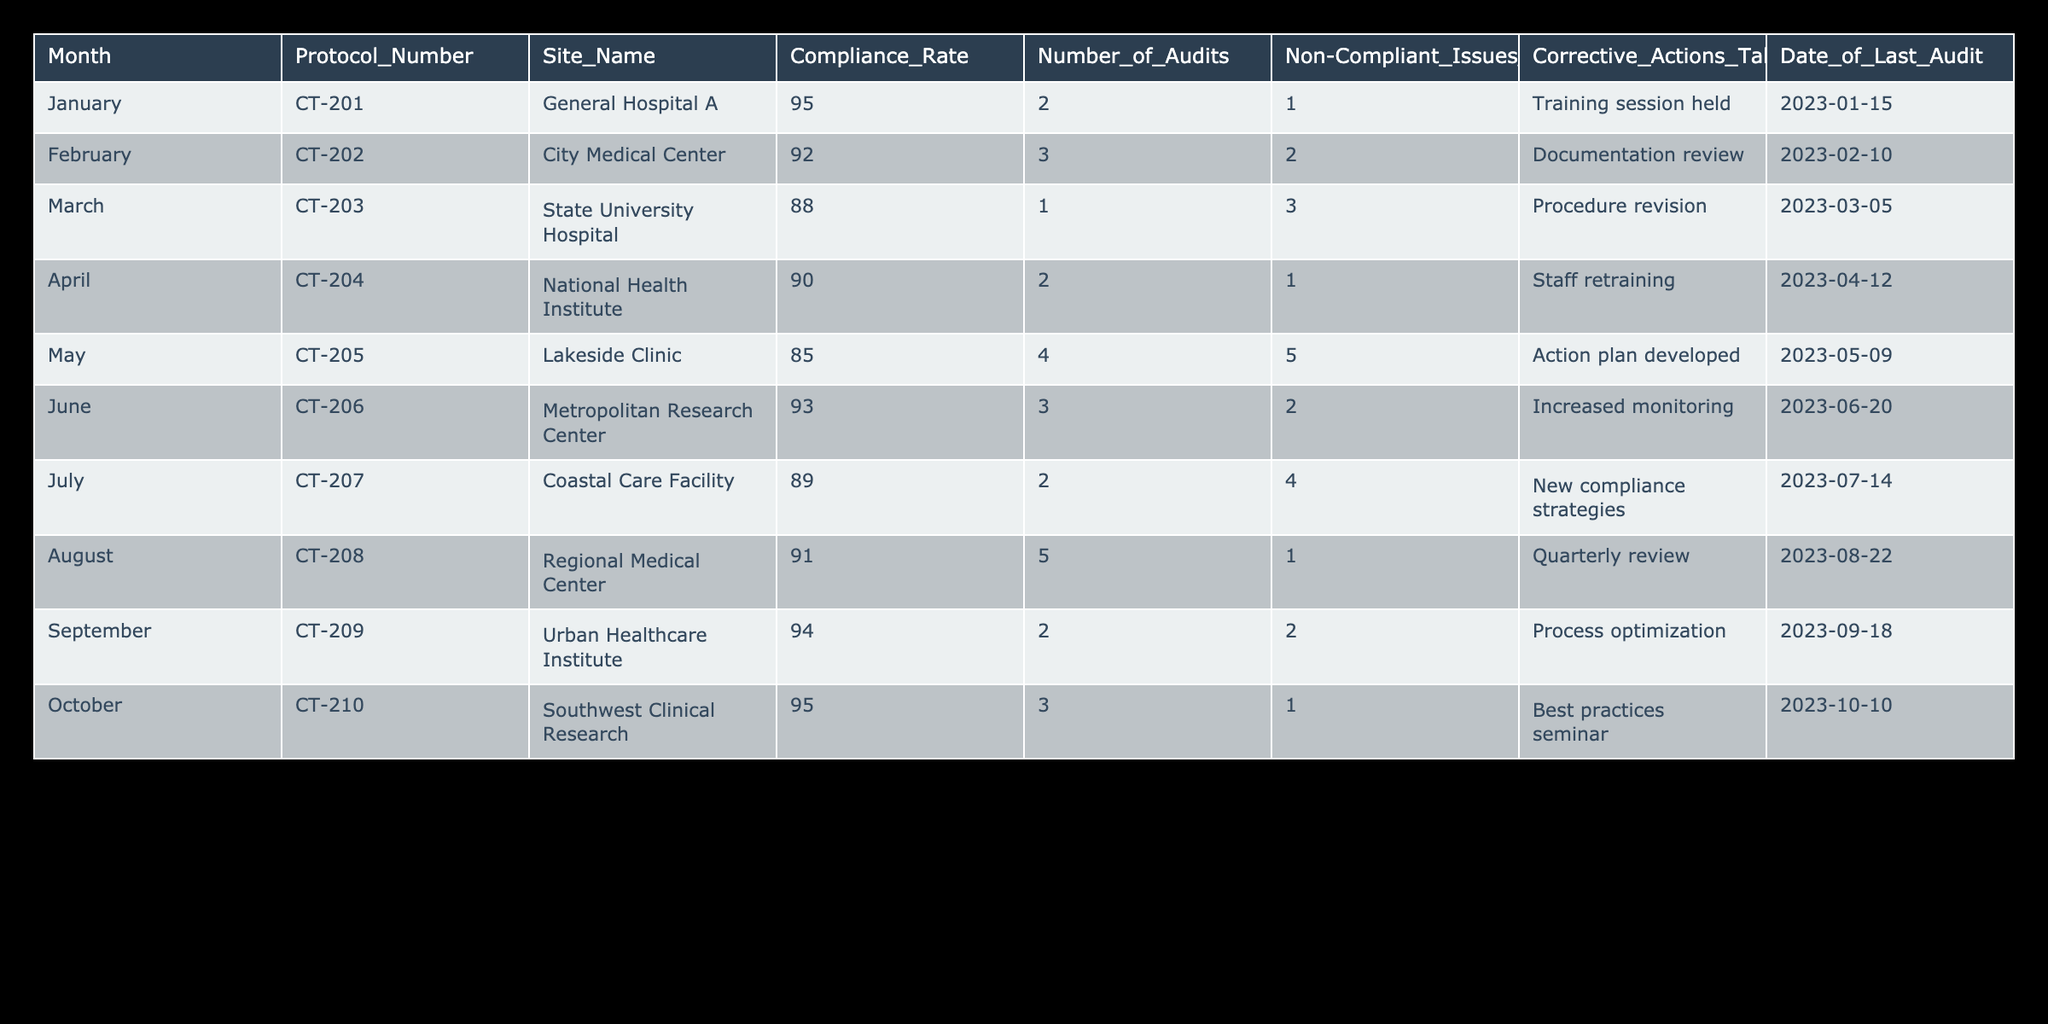What is the compliance rate for the Urban Healthcare Institute in September? According to the table, the compliance rate for the Urban Healthcare Institute in September is listed as 94%.
Answer: 94% What corrective action was taken by the Lakeside Clinic in May? The table indicates that the Lakeside Clinic identified five non-compliant issues in May and developed an action plan as a corrective action.
Answer: Action plan developed Which site had the highest compliance rate in October? From the table, both the Southwest Clinical Research and the General Hospital A had a compliance rate of 95% in October, but the question specifically asks for a site, which would be Southwest Clinical Research for October.
Answer: Southwest Clinical Research What is the average compliance rate across all months? The compliance rates are: 95, 92, 88, 90, 85, 93, 89, 91, 94, 95. Summing these rates gives us 919, and dividing by the number of entries (10) results in an average of 91.9%.
Answer: 91.9% Was there a month when the number of audits exceeded four? Looking at the table, May shows that Lakeside Clinic had four audits. However, there is no month with more than four audits. Therefore, the answer is no.
Answer: No Which protocol had the most non-compliant issues identified? Upon reviewing the table, Lakeside Clinic in May stands out with five non-compliant issues identified. This is the highest count across all entries.
Answer: CT-205 Which month had the lowest compliance rate and what was it? By examining the compliance rates, May has a compliance rate of 85%, which is lower than any other month on the list.
Answer: May, 85% How many sites had compliance rates above 90%? The compliance rates above 90% are found in the following months: January (95%), February (92%), June (93%), August (91%), September (94%), and October (95%). This totals six sites having compliance rates above 90%.
Answer: 6 What corrective action was taken at the State University Hospital in March? The table states that the State University Hospital had a procedure revision as its corrective action after identifying three non-compliant issues in March.
Answer: Procedure revision 